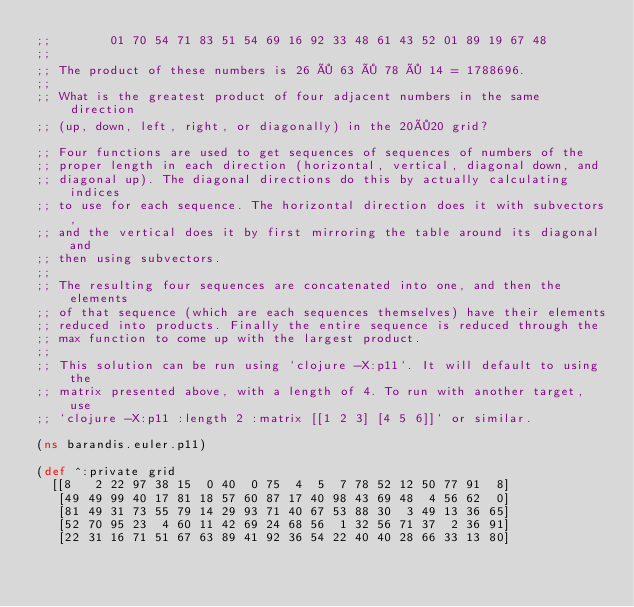<code> <loc_0><loc_0><loc_500><loc_500><_Clojure_>;;        01 70 54 71 83 51 54 69 16 92 33 48 61 43 52 01 89 19 67 48
;;
;; The product of these numbers is 26 × 63 × 78 × 14 = 1788696.
;;
;; What is the greatest product of four adjacent numbers in the same direction
;; (up, down, left, right, or diagonally) in the 20×20 grid?

;; Four functions are used to get sequences of sequences of numbers of the
;; proper length in each direction (horizontal, vertical, diagonal down, and
;; diagonal up). The diagonal directions do this by actually calculating indices
;; to use for each sequence. The horizontal direction does it with subvectors,
;; and the vertical does it by first mirroring the table around its diagonal and
;; then using subvectors.
;;
;; The resulting four sequences are concatenated into one, and then the elements
;; of that sequence (which are each sequences themselves) have their elements
;; reduced into products. Finally the entire sequence is reduced through the
;; max function to come up with the largest product.
;;
;; This solution can be run using `clojure -X:p11`. It will default to using the
;; matrix presented above, with a length of 4. To run with another target, use 
;; `clojure -X:p11 :length 2 :matrix [[1 2 3] [4 5 6]]` or similar.

(ns barandis.euler.p11)

(def ^:private grid
  [[8   2 22 97 38 15  0 40  0 75  4  5  7 78 52 12 50 77 91  8]
   [49 49 99 40 17 81 18 57 60 87 17 40 98 43 69 48  4 56 62  0]
   [81 49 31 73 55 79 14 29 93 71 40 67 53 88 30  3 49 13 36 65]
   [52 70 95 23  4 60 11 42 69 24 68 56  1 32 56 71 37  2 36 91]
   [22 31 16 71 51 67 63 89 41 92 36 54 22 40 40 28 66 33 13 80]</code> 